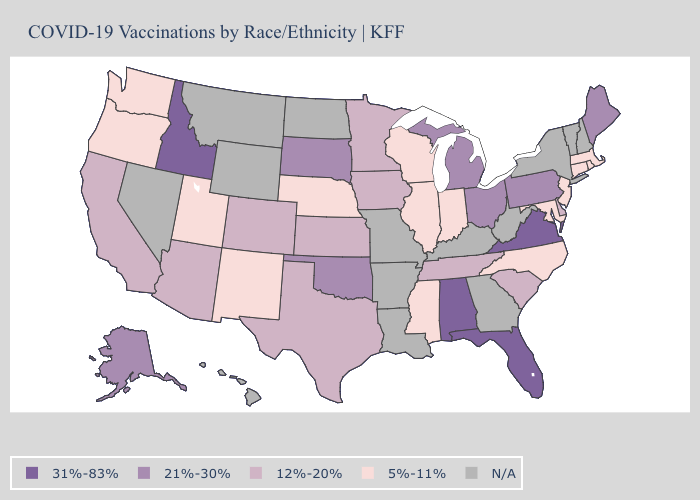Which states have the lowest value in the Northeast?
Quick response, please. Connecticut, Massachusetts, New Jersey, Rhode Island. Name the states that have a value in the range 12%-20%?
Short answer required. Arizona, California, Colorado, Delaware, Iowa, Kansas, Minnesota, South Carolina, Tennessee, Texas. What is the lowest value in the USA?
Write a very short answer. 5%-11%. Among the states that border North Dakota , which have the highest value?
Keep it brief. South Dakota. Name the states that have a value in the range 21%-30%?
Give a very brief answer. Alaska, Maine, Michigan, Ohio, Oklahoma, Pennsylvania, South Dakota. Name the states that have a value in the range 12%-20%?
Concise answer only. Arizona, California, Colorado, Delaware, Iowa, Kansas, Minnesota, South Carolina, Tennessee, Texas. What is the value of Wisconsin?
Quick response, please. 5%-11%. Name the states that have a value in the range 12%-20%?
Write a very short answer. Arizona, California, Colorado, Delaware, Iowa, Kansas, Minnesota, South Carolina, Tennessee, Texas. Name the states that have a value in the range 31%-83%?
Give a very brief answer. Alabama, Florida, Idaho, Virginia. What is the value of Colorado?
Write a very short answer. 12%-20%. What is the value of Missouri?
Short answer required. N/A. Does Wisconsin have the highest value in the MidWest?
Answer briefly. No. What is the lowest value in the Northeast?
Answer briefly. 5%-11%. Name the states that have a value in the range 12%-20%?
Concise answer only. Arizona, California, Colorado, Delaware, Iowa, Kansas, Minnesota, South Carolina, Tennessee, Texas. 